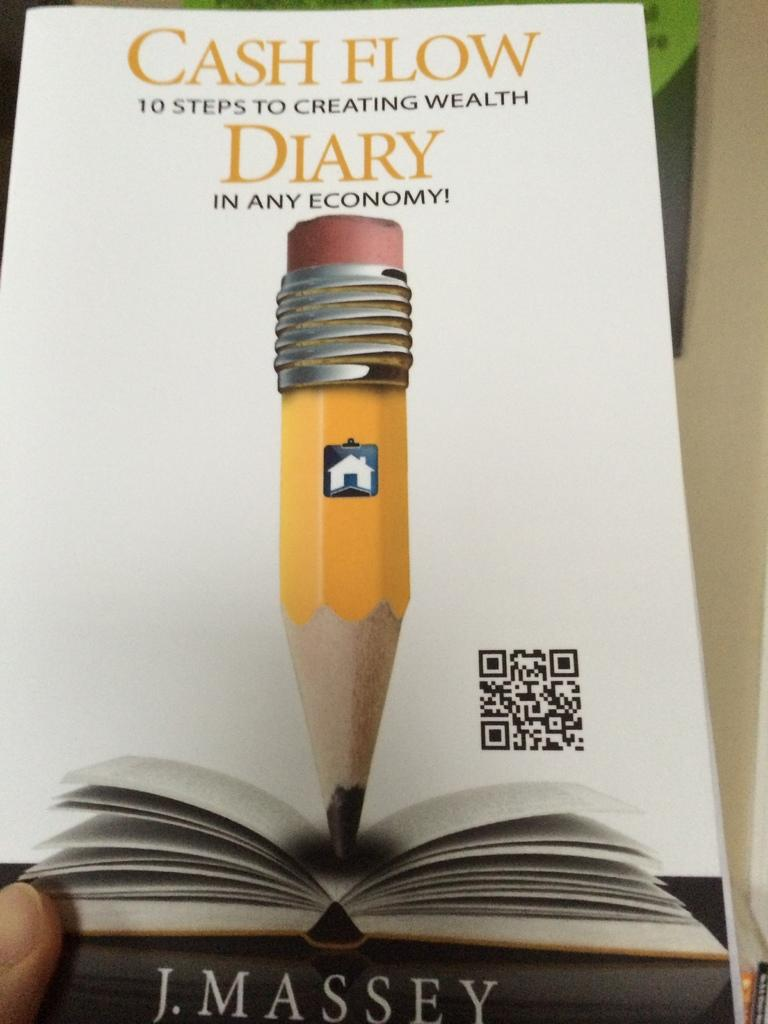<image>
Provide a brief description of the given image. The front of a book cover that reads CASH FLOW DIARY. 